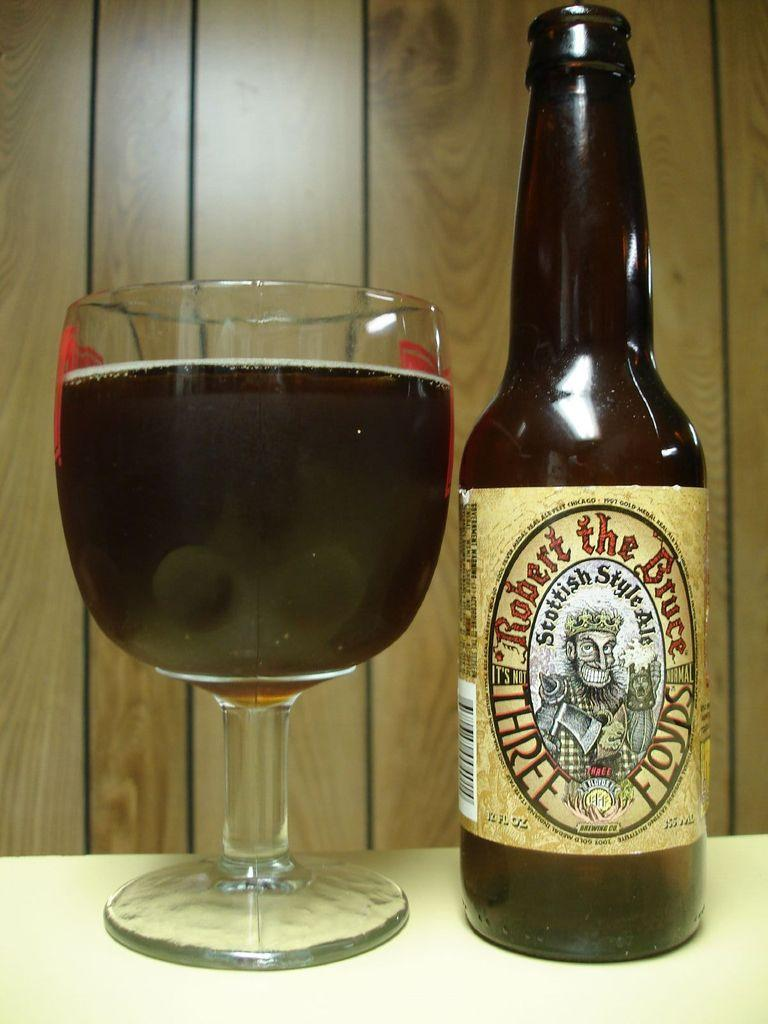<image>
Share a concise interpretation of the image provided. A bottle of Robert the Bruce Three Floyds is next to a glass of beer 